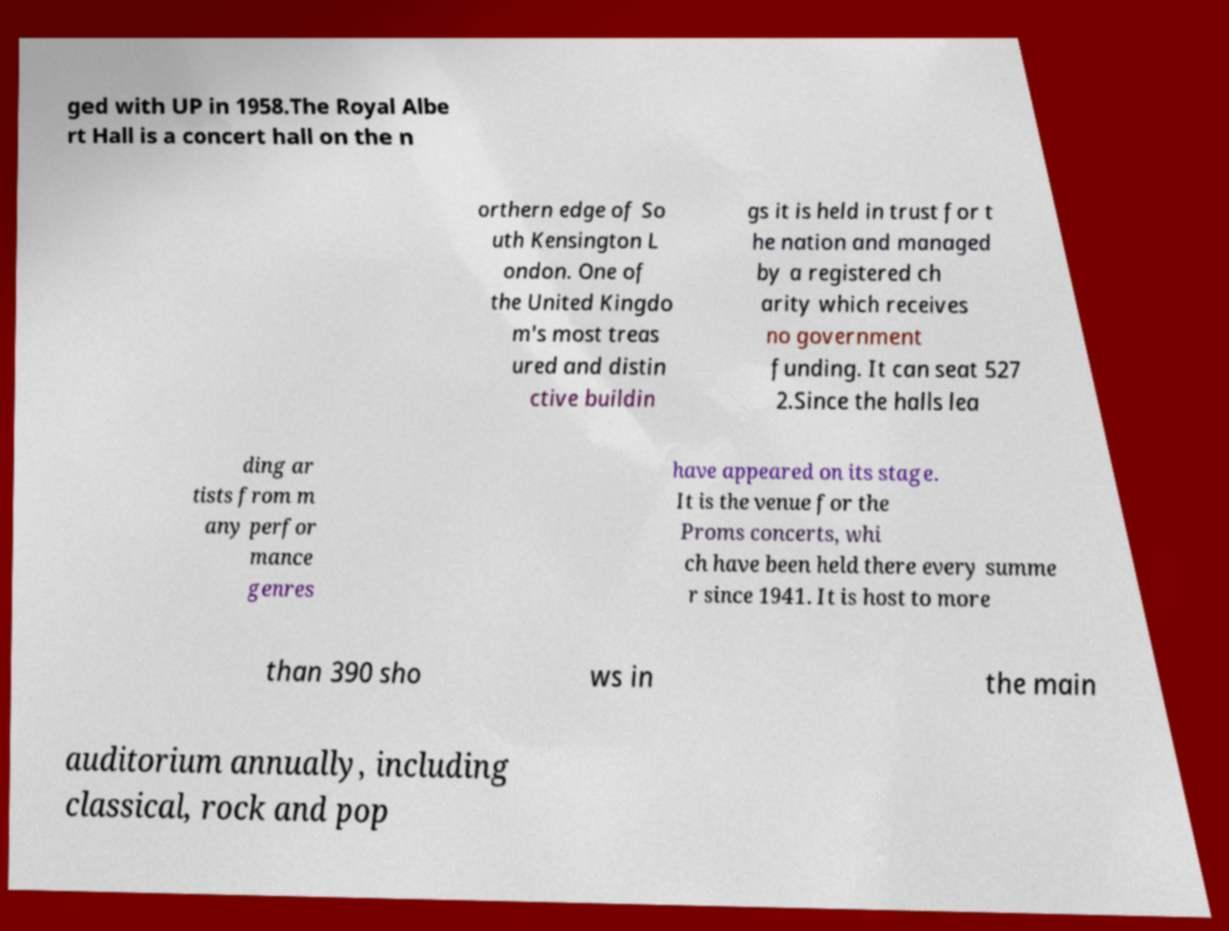Please identify and transcribe the text found in this image. ged with UP in 1958.The Royal Albe rt Hall is a concert hall on the n orthern edge of So uth Kensington L ondon. One of the United Kingdo m's most treas ured and distin ctive buildin gs it is held in trust for t he nation and managed by a registered ch arity which receives no government funding. It can seat 527 2.Since the halls lea ding ar tists from m any perfor mance genres have appeared on its stage. It is the venue for the Proms concerts, whi ch have been held there every summe r since 1941. It is host to more than 390 sho ws in the main auditorium annually, including classical, rock and pop 